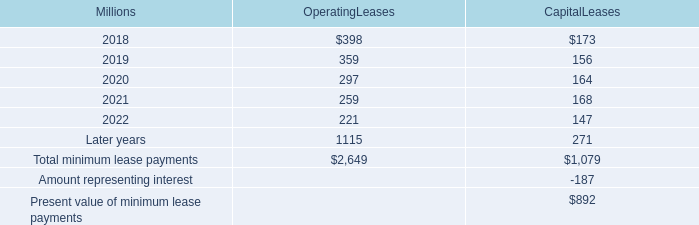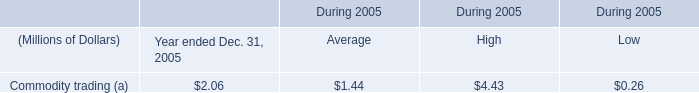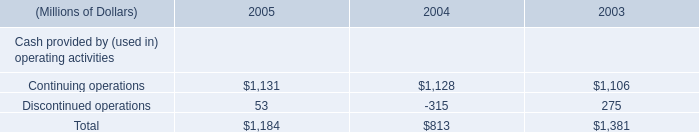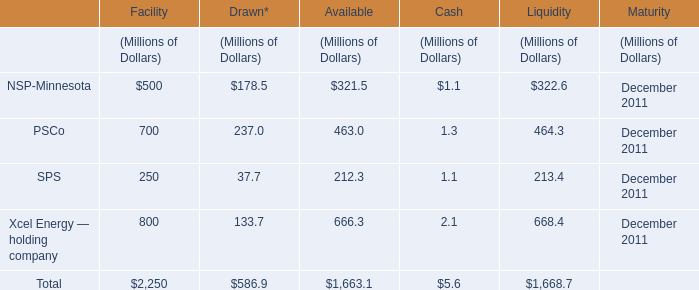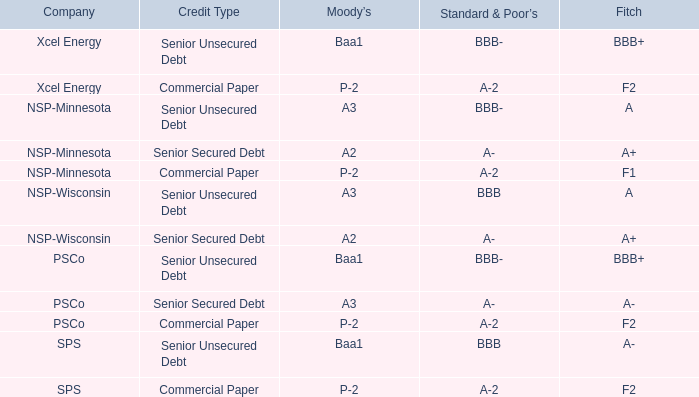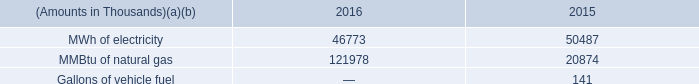What do all Facility sum up for Facility , excluding NSP-Minnesota and PSCo? (in Million) 
Computations: (250 + 800)
Answer: 1050.0. 